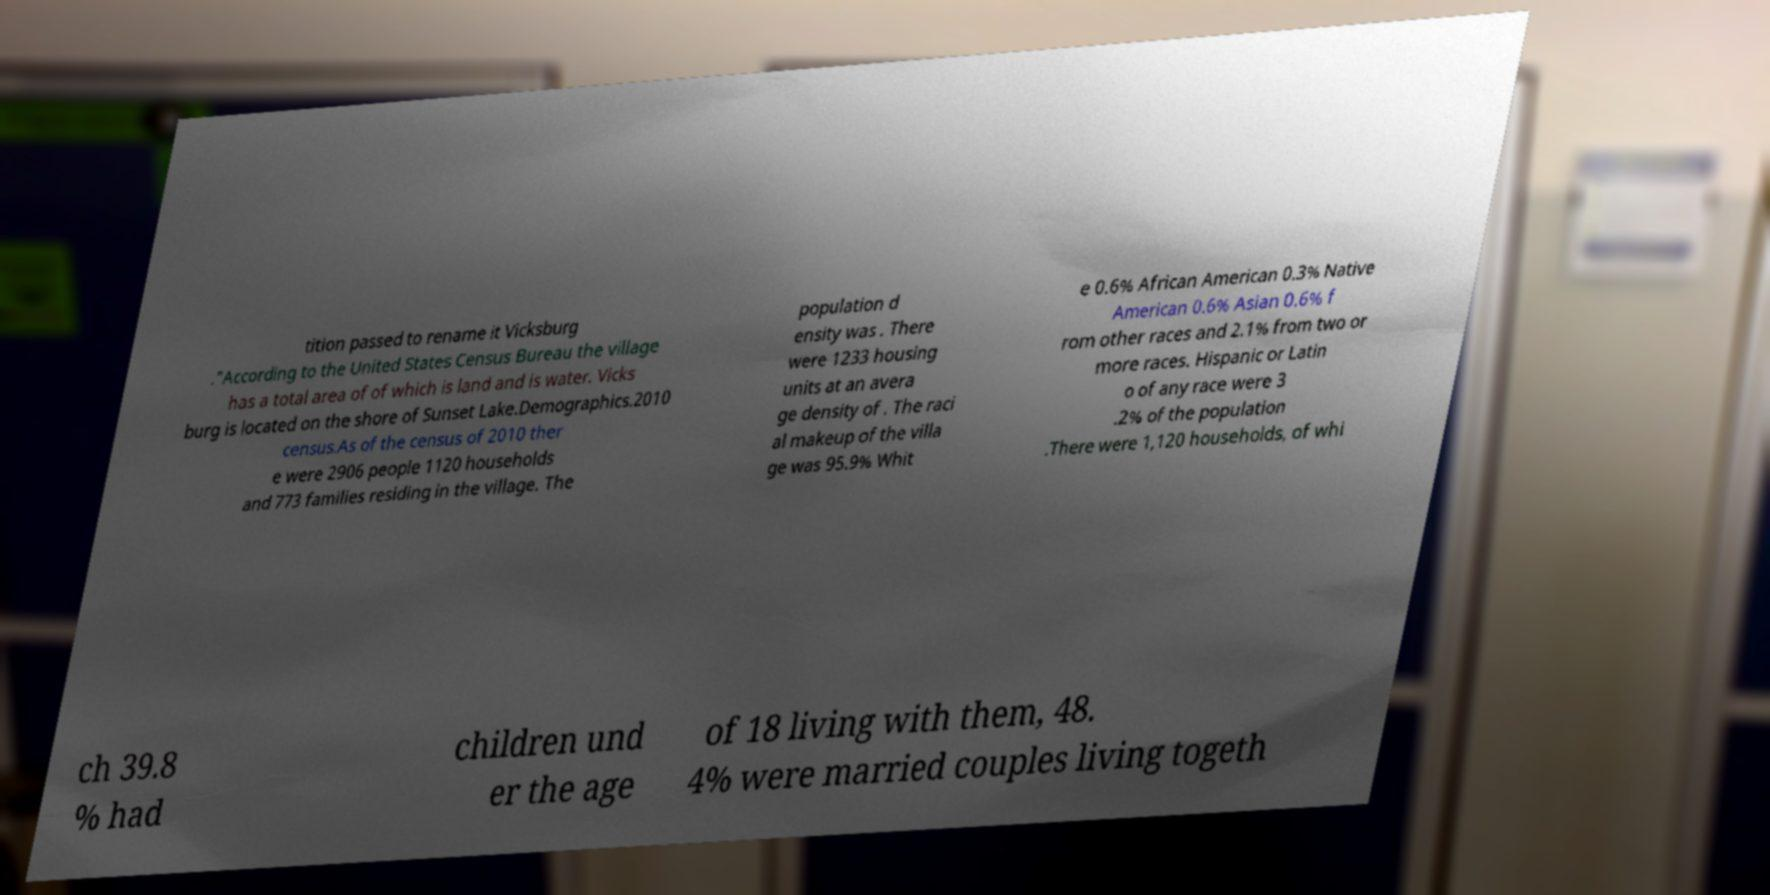For documentation purposes, I need the text within this image transcribed. Could you provide that? tition passed to rename it Vicksburg ."According to the United States Census Bureau the village has a total area of of which is land and is water. Vicks burg is located on the shore of Sunset Lake.Demographics.2010 census.As of the census of 2010 ther e were 2906 people 1120 households and 773 families residing in the village. The population d ensity was . There were 1233 housing units at an avera ge density of . The raci al makeup of the villa ge was 95.9% Whit e 0.6% African American 0.3% Native American 0.6% Asian 0.6% f rom other races and 2.1% from two or more races. Hispanic or Latin o of any race were 3 .2% of the population .There were 1,120 households, of whi ch 39.8 % had children und er the age of 18 living with them, 48. 4% were married couples living togeth 